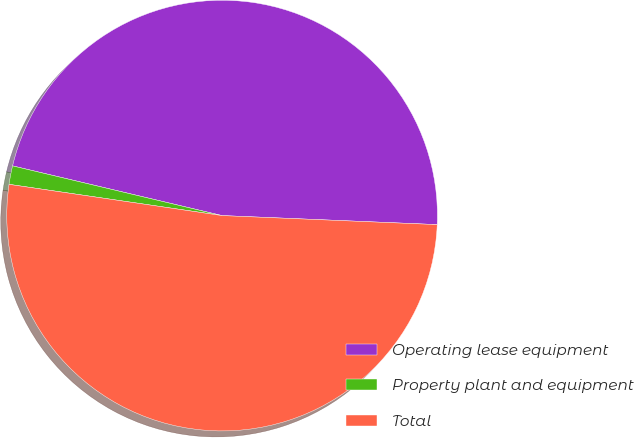Convert chart. <chart><loc_0><loc_0><loc_500><loc_500><pie_chart><fcel>Operating lease equipment<fcel>Property plant and equipment<fcel>Total<nl><fcel>46.96%<fcel>1.39%<fcel>51.65%<nl></chart> 